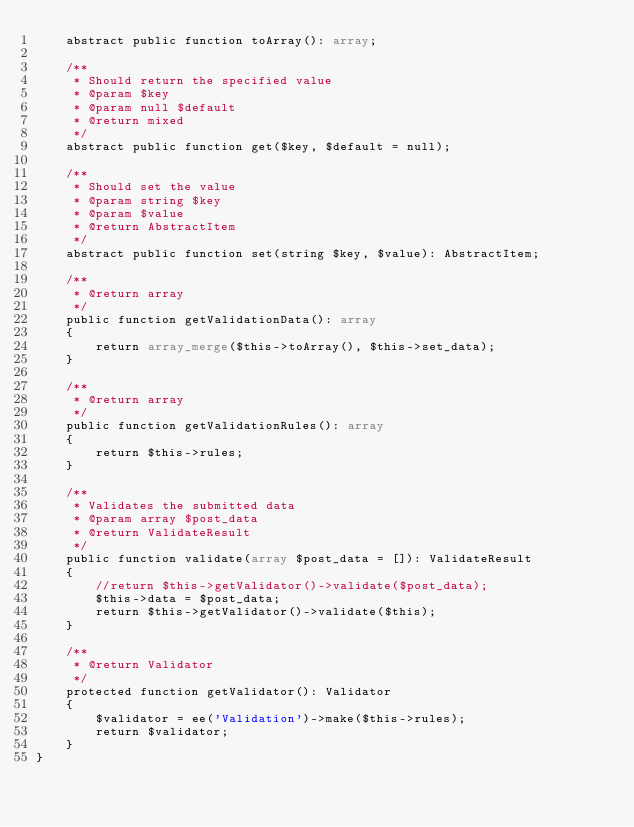<code> <loc_0><loc_0><loc_500><loc_500><_PHP_>    abstract public function toArray(): array;

    /**
     * Should return the specified value
     * @param $key
     * @param null $default
     * @return mixed
     */
    abstract public function get($key, $default = null);

    /**
     * Should set the value
     * @param string $key
     * @param $value
     * @return AbstractItem
     */
    abstract public function set(string $key, $value): AbstractItem;

    /**
     * @return array
     */
    public function getValidationData(): array
    {
        return array_merge($this->toArray(), $this->set_data);
    }

    /**
     * @return array
     */
    public function getValidationRules(): array
    {
        return $this->rules;
    }

    /**
     * Validates the submitted data
     * @param array $post_data
     * @return ValidateResult
     */
    public function validate(array $post_data = []): ValidateResult
    {
        //return $this->getValidator()->validate($post_data);
        $this->data = $post_data;
        return $this->getValidator()->validate($this);
    }

    /**
     * @return Validator
     */
    protected function getValidator(): Validator
    {
        $validator = ee('Validation')->make($this->rules);
        return $validator;
    }
}
</code> 